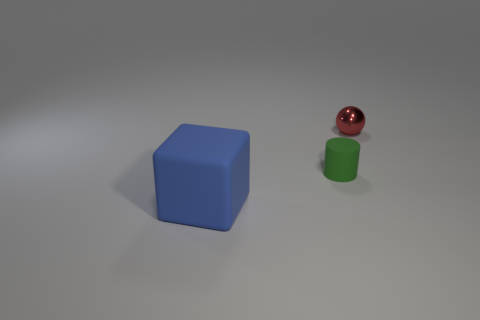Add 3 rubber blocks. How many objects exist? 6 Subtract all balls. How many objects are left? 2 Add 3 shiny balls. How many shiny balls are left? 4 Add 1 gray rubber cylinders. How many gray rubber cylinders exist? 1 Subtract 0 brown cubes. How many objects are left? 3 Subtract all large blue things. Subtract all green matte objects. How many objects are left? 1 